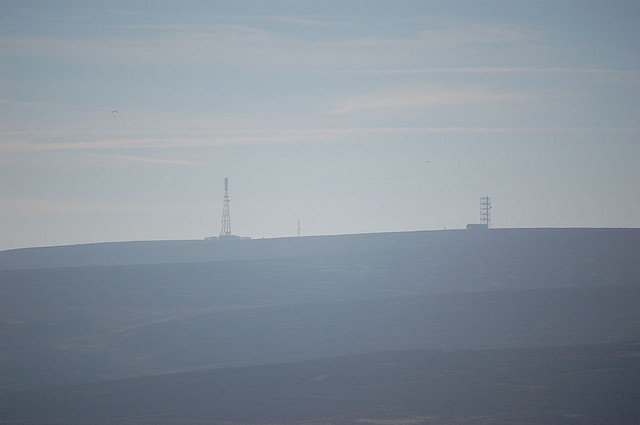Describe the objects in this image and their specific colors. I can see various objects in this image with different colors. 